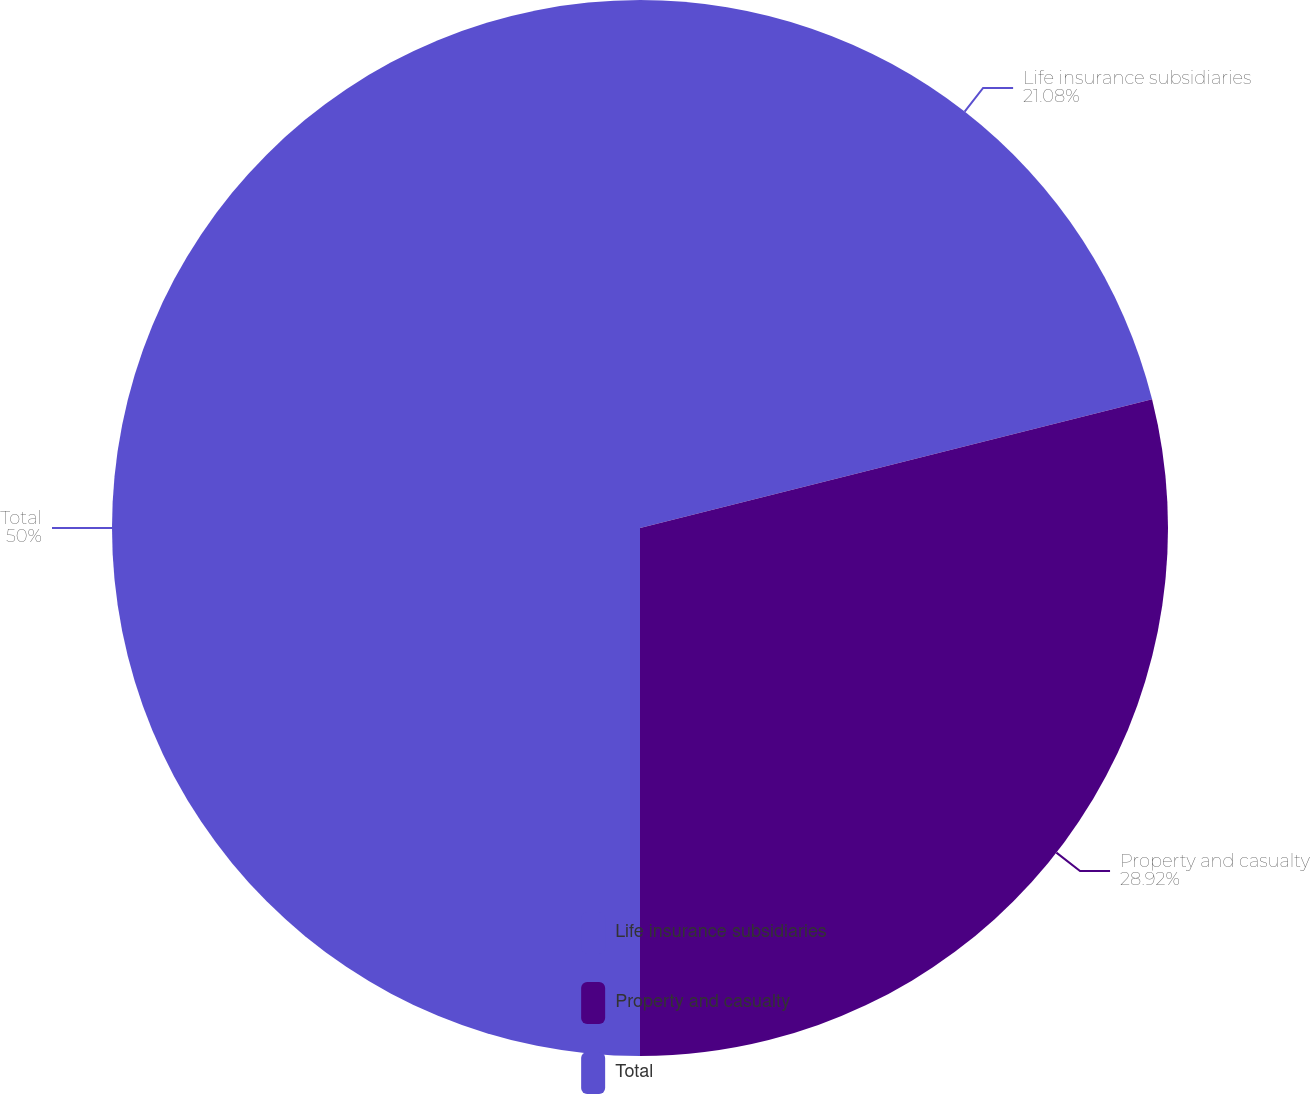<chart> <loc_0><loc_0><loc_500><loc_500><pie_chart><fcel>Life insurance subsidiaries<fcel>Property and casualty<fcel>Total<nl><fcel>21.08%<fcel>28.92%<fcel>50.0%<nl></chart> 